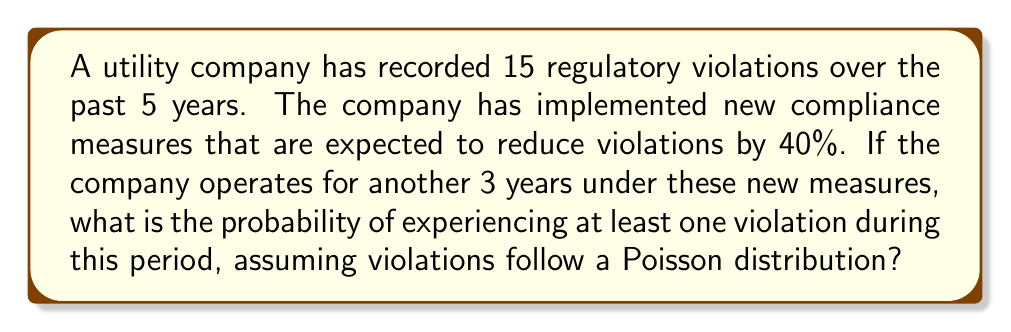Give your solution to this math problem. To solve this problem, we'll follow these steps:

1. Calculate the original rate of violations per year:
   $\lambda_{\text{original}} = \frac{15 \text{ violations}}{5 \text{ years}} = 3 \text{ violations/year}$

2. Calculate the new rate of violations per year after implementing compliance measures:
   $\lambda_{\text{new}} = \lambda_{\text{original}} \times (1 - 0.40) = 3 \times 0.60 = 1.8 \text{ violations/year}$

3. Calculate the expected number of violations over 3 years under new measures:
   $\lambda_{\text{3 years}} = 1.8 \text{ violations/year} \times 3 \text{ years} = 5.4 \text{ violations}$

4. The probability of at least one violation is the complement of the probability of zero violations. For a Poisson distribution:
   $P(X = k) = \frac{e^{-\lambda}\lambda^k}{k!}$

   $P(\text{at least one violation}) = 1 - P(\text{zero violations})$
   
   $= 1 - P(X = 0) = 1 - \frac{e^{-5.4}(5.4)^0}{0!} = 1 - e^{-5.4}$

5. Calculate the final probability:
   $P(\text{at least one violation}) = 1 - e^{-5.4} \approx 0.9955$ or 99.55%
Answer: $1 - e^{-5.4} \approx 0.9955$ or 99.55% 